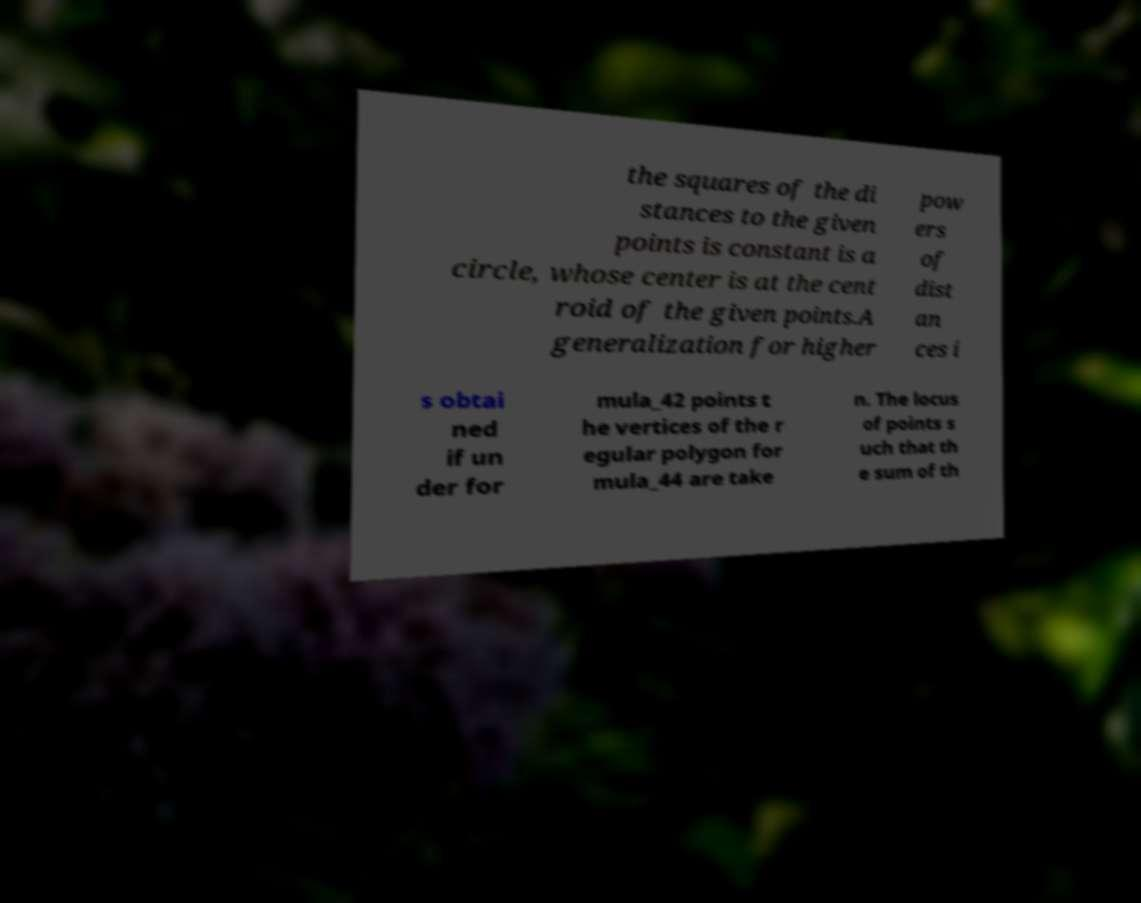Could you assist in decoding the text presented in this image and type it out clearly? the squares of the di stances to the given points is constant is a circle, whose center is at the cent roid of the given points.A generalization for higher pow ers of dist an ces i s obtai ned if un der for mula_42 points t he vertices of the r egular polygon for mula_44 are take n. The locus of points s uch that th e sum of th 